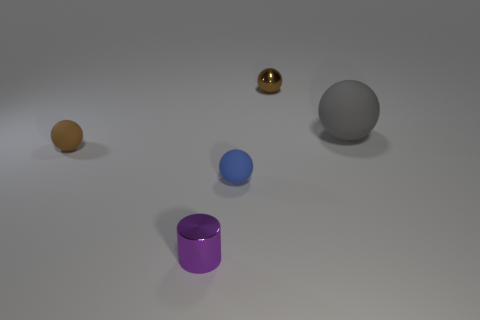How do the objects appear in terms of their sizes relative to each other? Relative to each other, the grey spherical object is the largest. The purple cylinder and the golden sphere are smaller, while the yellow and blue spheroids are the smallest items in the group. 